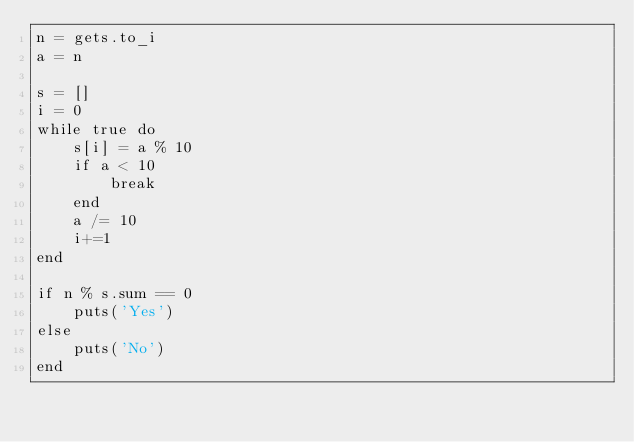Convert code to text. <code><loc_0><loc_0><loc_500><loc_500><_Ruby_>n = gets.to_i
a = n

s = []
i = 0
while true do
    s[i] = a % 10
    if a < 10
        break
    end
    a /= 10
    i+=1
end

if n % s.sum == 0
    puts('Yes')
else
    puts('No')
end</code> 